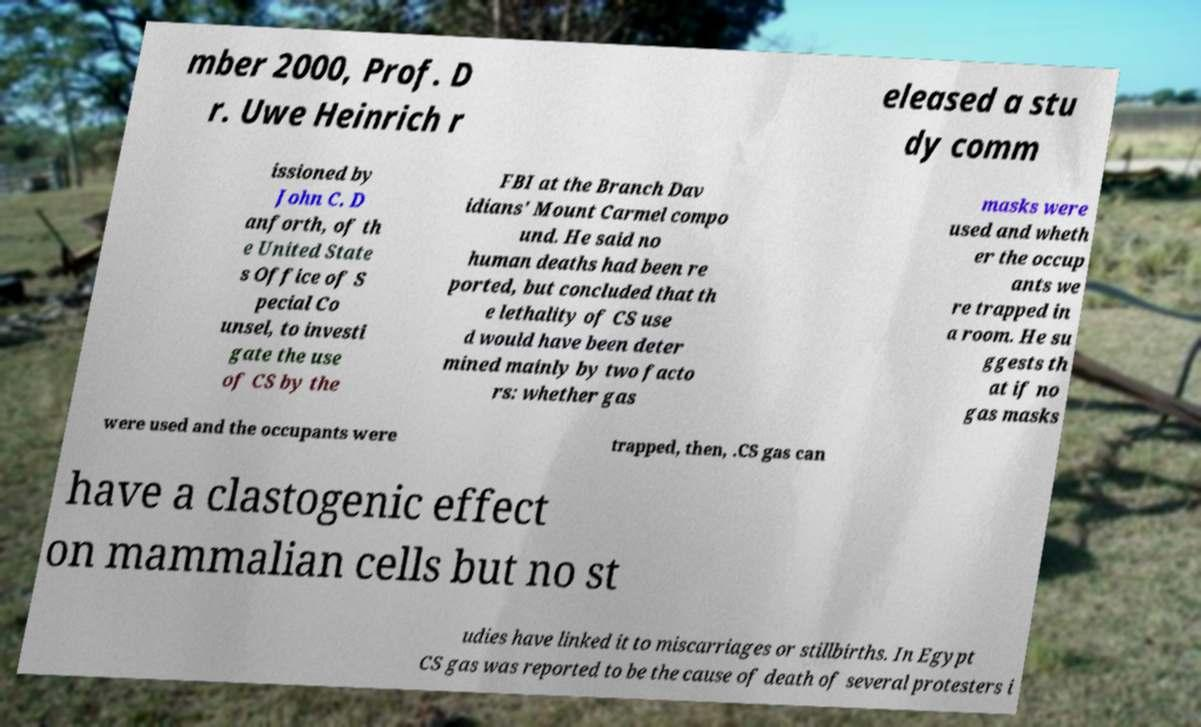What messages or text are displayed in this image? I need them in a readable, typed format. mber 2000, Prof. D r. Uwe Heinrich r eleased a stu dy comm issioned by John C. D anforth, of th e United State s Office of S pecial Co unsel, to investi gate the use of CS by the FBI at the Branch Dav idians' Mount Carmel compo und. He said no human deaths had been re ported, but concluded that th e lethality of CS use d would have been deter mined mainly by two facto rs: whether gas masks were used and wheth er the occup ants we re trapped in a room. He su ggests th at if no gas masks were used and the occupants were trapped, then, .CS gas can have a clastogenic effect on mammalian cells but no st udies have linked it to miscarriages or stillbirths. In Egypt CS gas was reported to be the cause of death of several protesters i 